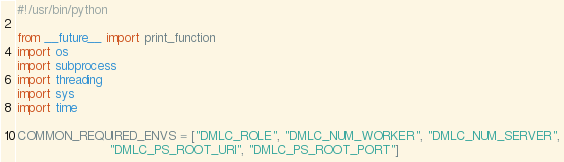<code> <loc_0><loc_0><loc_500><loc_500><_Python_>#!/usr/bin/python

from __future__ import print_function
import os
import subprocess
import threading
import sys
import time

COMMON_REQUIRED_ENVS = ["DMLC_ROLE", "DMLC_NUM_WORKER", "DMLC_NUM_SERVER",
                        "DMLC_PS_ROOT_URI", "DMLC_PS_ROOT_PORT"]</code> 